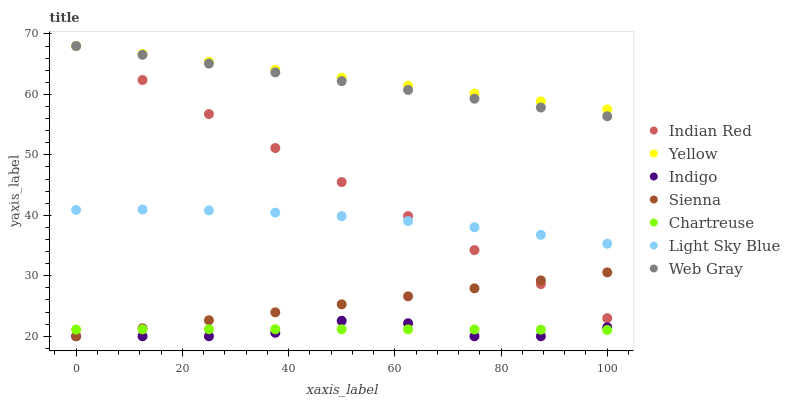Does Indigo have the minimum area under the curve?
Answer yes or no. Yes. Does Yellow have the maximum area under the curve?
Answer yes or no. Yes. Does Yellow have the minimum area under the curve?
Answer yes or no. No. Does Indigo have the maximum area under the curve?
Answer yes or no. No. Is Sienna the smoothest?
Answer yes or no. Yes. Is Indigo the roughest?
Answer yes or no. Yes. Is Yellow the smoothest?
Answer yes or no. No. Is Yellow the roughest?
Answer yes or no. No. Does Indigo have the lowest value?
Answer yes or no. Yes. Does Yellow have the lowest value?
Answer yes or no. No. Does Indian Red have the highest value?
Answer yes or no. Yes. Does Indigo have the highest value?
Answer yes or no. No. Is Chartreuse less than Indian Red?
Answer yes or no. Yes. Is Yellow greater than Light Sky Blue?
Answer yes or no. Yes. Does Sienna intersect Indian Red?
Answer yes or no. Yes. Is Sienna less than Indian Red?
Answer yes or no. No. Is Sienna greater than Indian Red?
Answer yes or no. No. Does Chartreuse intersect Indian Red?
Answer yes or no. No. 